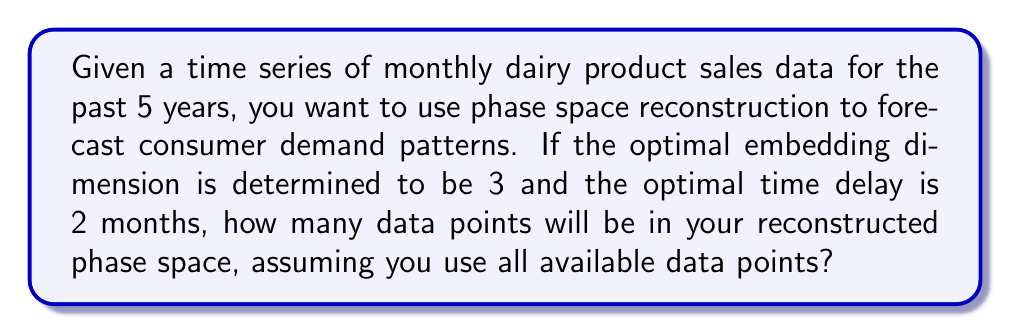Can you solve this math problem? To solve this problem, we need to follow these steps:

1. Understand the given information:
   - We have 5 years of monthly data
   - The embedding dimension (m) is 3
   - The time delay (τ) is 2 months

2. Calculate the total number of data points in the original time series:
   - 5 years * 12 months/year = 60 data points

3. Apply the phase space reconstruction formula:
   The number of points in the reconstructed phase space (N) is given by:
   $$N = n - (m-1)τ$$
   Where:
   n = total number of data points in the original time series
   m = embedding dimension
   τ = time delay

4. Substitute the values:
   $$N = 60 - (3-1)2$$
   $$N = 60 - 4$$
   $$N = 56$$

Therefore, the reconstructed phase space will contain 56 data points.
Answer: 56 data points 